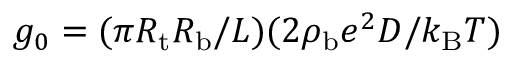Convert formula to latex. <formula><loc_0><loc_0><loc_500><loc_500>g _ { 0 } = ( \pi R _ { t } R _ { b } / L ) ( 2 \rho _ { b } e ^ { 2 } D / k _ { B } T )</formula> 